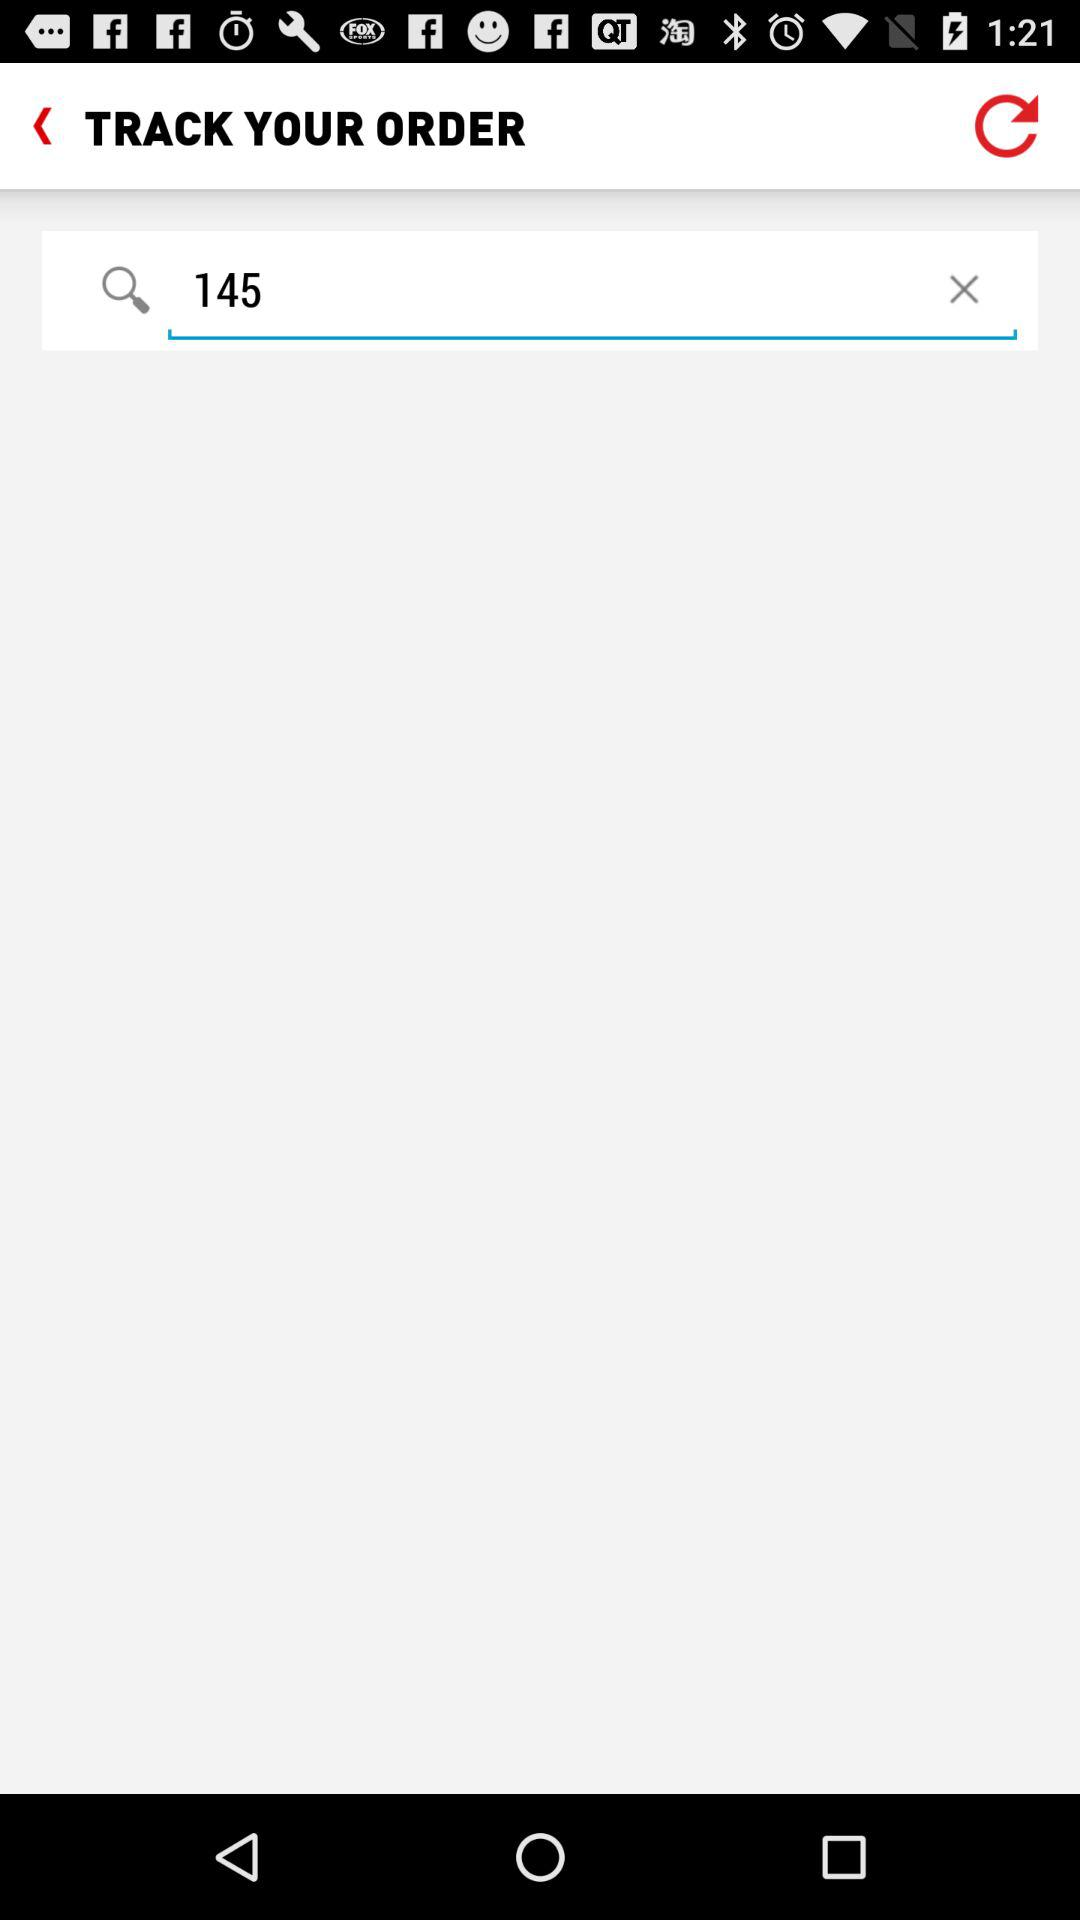What is the number in the search bar? The number in the search bar is 145. 